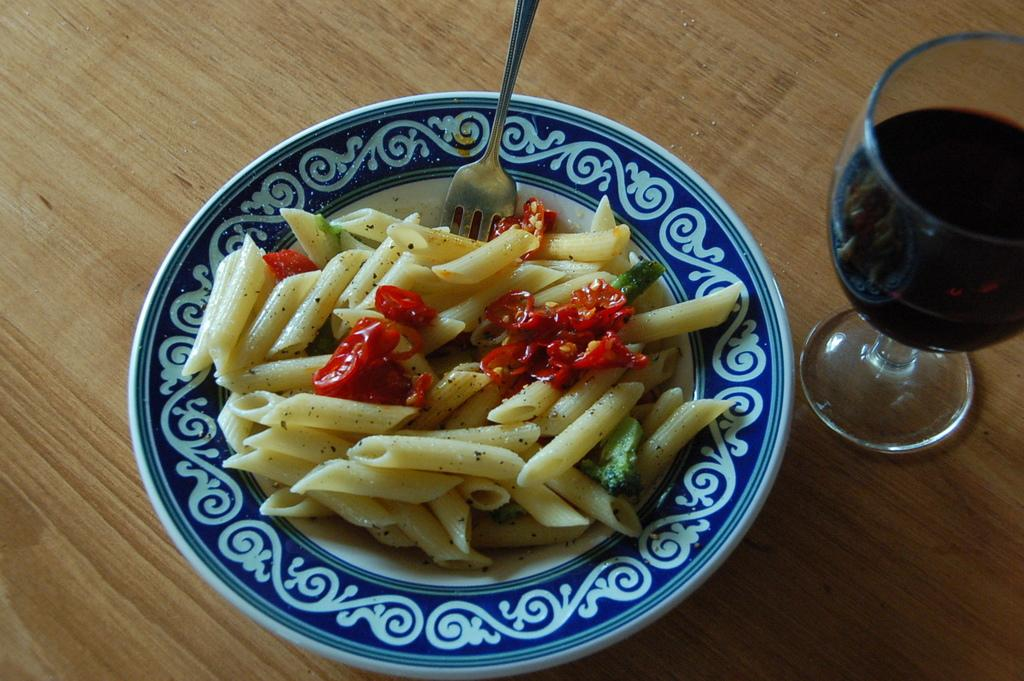What type of food is visible in the image? There is pasta with veggies in the image. What utensil is present in the image? There is a fork in the image. What is in the glass that is visible in the image? There is a glass with liquid in the image. What surface is the food and glass placed on in the image? There is a table in the image. How does the pasta with veggies surprise the hand in the image? There is no hand present in the image, and the pasta with veggies does not interact with any hands. 